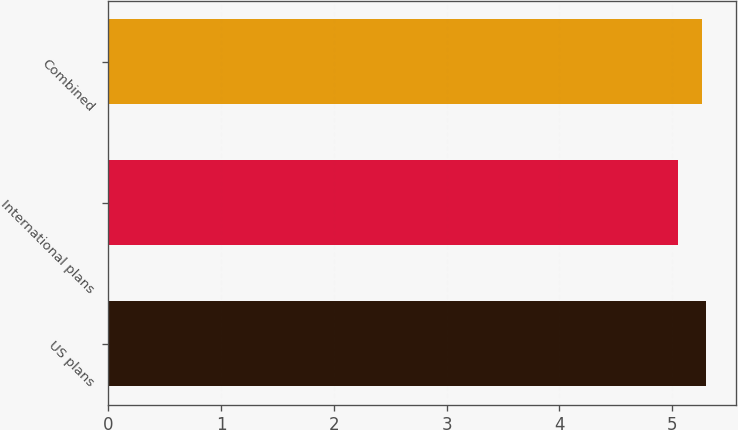Convert chart to OTSL. <chart><loc_0><loc_0><loc_500><loc_500><bar_chart><fcel>US plans<fcel>International plans<fcel>Combined<nl><fcel>5.3<fcel>5.05<fcel>5.26<nl></chart> 